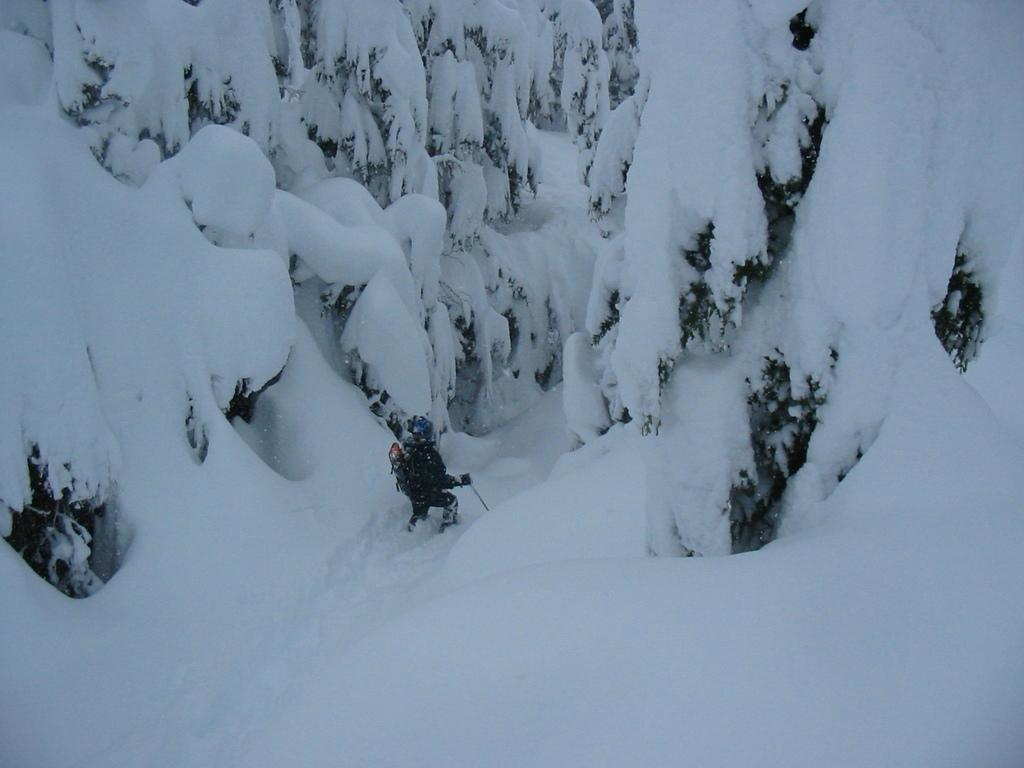What is the condition of the trees in the image? The trees in the image are covered with snow. Can you describe the person in the image? There is a person in the image, and they are holding a stick. What type of office furniture can be seen in the image? There is no office furniture present in the image; it features snow-covered trees and a person holding a stick. 